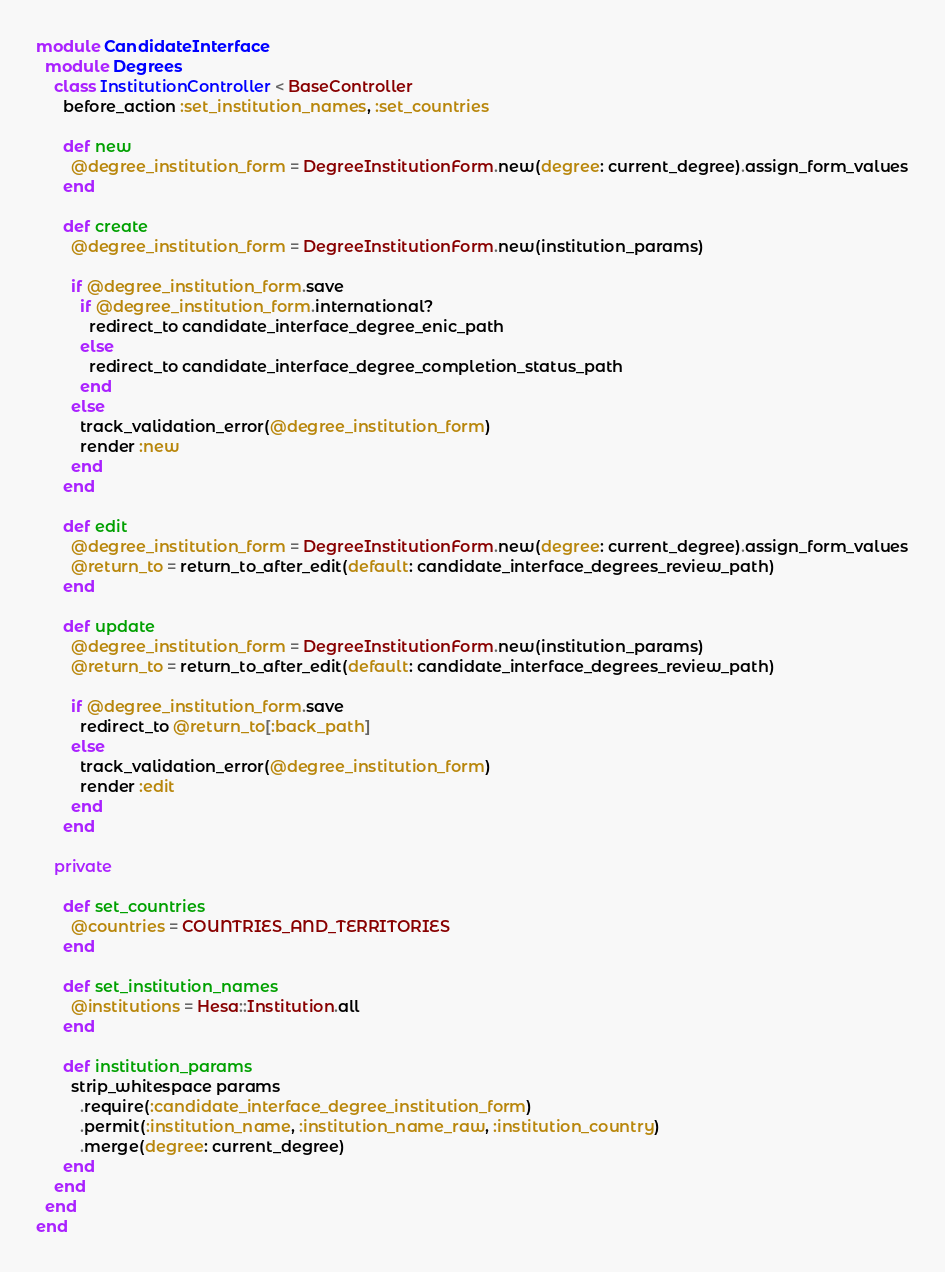<code> <loc_0><loc_0><loc_500><loc_500><_Ruby_>module CandidateInterface
  module Degrees
    class InstitutionController < BaseController
      before_action :set_institution_names, :set_countries

      def new
        @degree_institution_form = DegreeInstitutionForm.new(degree: current_degree).assign_form_values
      end

      def create
        @degree_institution_form = DegreeInstitutionForm.new(institution_params)

        if @degree_institution_form.save
          if @degree_institution_form.international?
            redirect_to candidate_interface_degree_enic_path
          else
            redirect_to candidate_interface_degree_completion_status_path
          end
        else
          track_validation_error(@degree_institution_form)
          render :new
        end
      end

      def edit
        @degree_institution_form = DegreeInstitutionForm.new(degree: current_degree).assign_form_values
        @return_to = return_to_after_edit(default: candidate_interface_degrees_review_path)
      end

      def update
        @degree_institution_form = DegreeInstitutionForm.new(institution_params)
        @return_to = return_to_after_edit(default: candidate_interface_degrees_review_path)

        if @degree_institution_form.save
          redirect_to @return_to[:back_path]
        else
          track_validation_error(@degree_institution_form)
          render :edit
        end
      end

    private

      def set_countries
        @countries = COUNTRIES_AND_TERRITORIES
      end

      def set_institution_names
        @institutions = Hesa::Institution.all
      end

      def institution_params
        strip_whitespace params
          .require(:candidate_interface_degree_institution_form)
          .permit(:institution_name, :institution_name_raw, :institution_country)
          .merge(degree: current_degree)
      end
    end
  end
end
</code> 